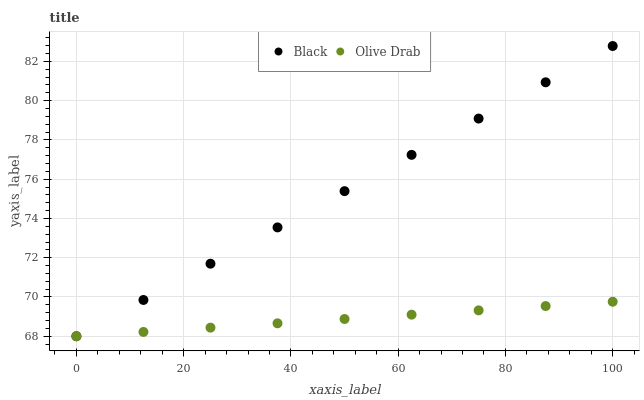Does Olive Drab have the minimum area under the curve?
Answer yes or no. Yes. Does Black have the maximum area under the curve?
Answer yes or no. Yes. Does Olive Drab have the maximum area under the curve?
Answer yes or no. No. Is Olive Drab the smoothest?
Answer yes or no. Yes. Is Black the roughest?
Answer yes or no. Yes. Is Olive Drab the roughest?
Answer yes or no. No. Does Black have the lowest value?
Answer yes or no. Yes. Does Black have the highest value?
Answer yes or no. Yes. Does Olive Drab have the highest value?
Answer yes or no. No. Does Black intersect Olive Drab?
Answer yes or no. Yes. Is Black less than Olive Drab?
Answer yes or no. No. Is Black greater than Olive Drab?
Answer yes or no. No. 